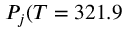<formula> <loc_0><loc_0><loc_500><loc_500>P _ { j } ( T = 3 2 1 . 9</formula> 